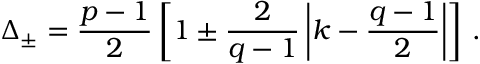Convert formula to latex. <formula><loc_0><loc_0><loc_500><loc_500>\Delta _ { \pm } = { \frac { p - 1 } { 2 } } \left [ 1 \pm { \frac { 2 } { q - 1 } } \left | k - { \frac { q - 1 } { 2 } } \right | \right ] \, .</formula> 